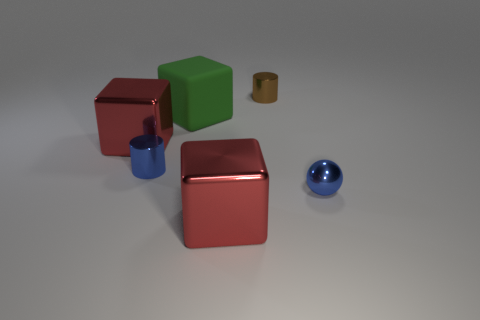Subtract all metal cubes. How many cubes are left? 1 Add 4 big matte objects. How many objects exist? 10 Subtract all red cubes. How many cubes are left? 1 Subtract all balls. How many objects are left? 5 Subtract 1 cylinders. How many cylinders are left? 1 Subtract all yellow cylinders. How many green blocks are left? 1 Subtract all small blocks. Subtract all small balls. How many objects are left? 5 Add 1 small brown shiny cylinders. How many small brown shiny cylinders are left? 2 Add 4 spheres. How many spheres exist? 5 Subtract 1 blue spheres. How many objects are left? 5 